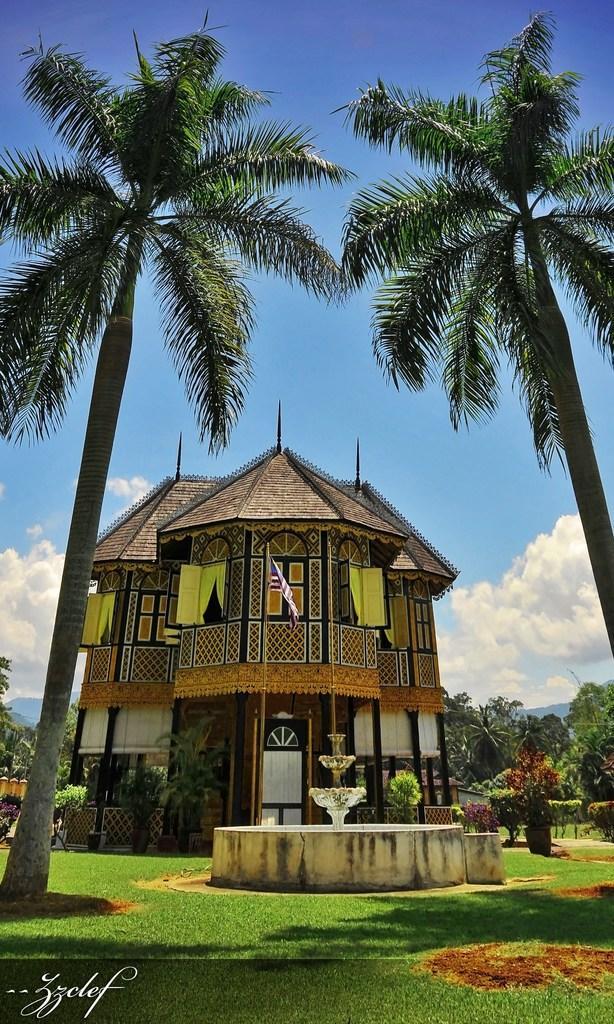Can you describe this image briefly? In the picture we can see the grass surface, on it we can see the two coconut trees and in the middle of it, we can see a fountain and behind it, we can see the house and in the background we can see the trees and the sky with clouds. 